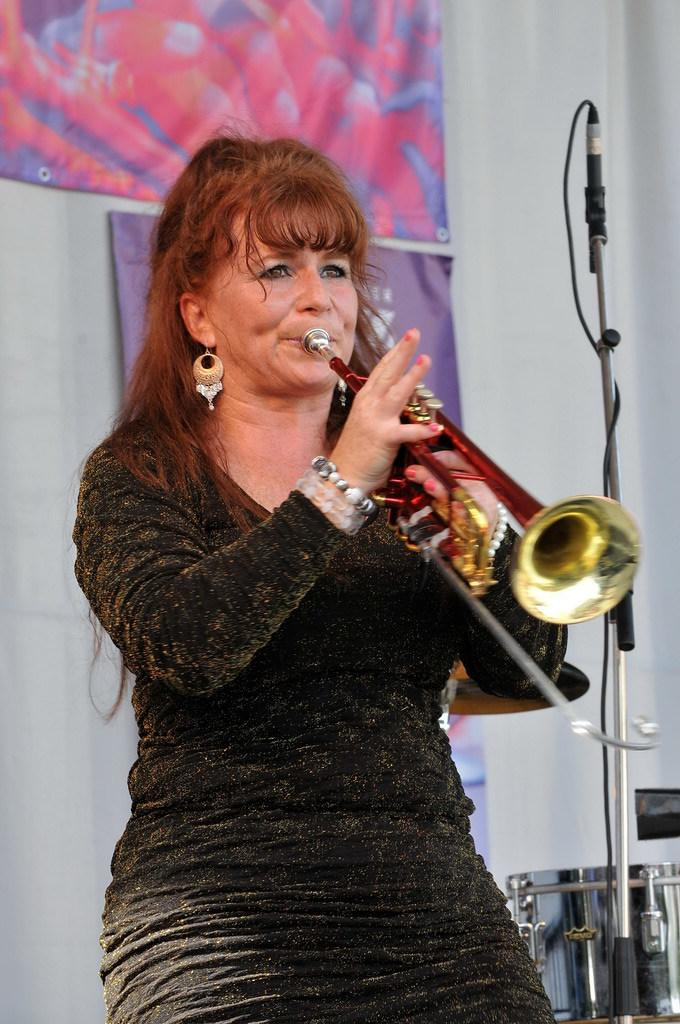What is the lady in the image doing? The lady is playing a musical instrument in the image. What can be seen on the right side of the image? There is a stand on the right side of the image. What is visible in the background of the image? There is a band, a curtain, and a banner in the background of the image. What type of creature is sitting on the lady's stomach while she plays the musical instrument? There is no creature present on the lady's stomach or anywhere else in the image. 